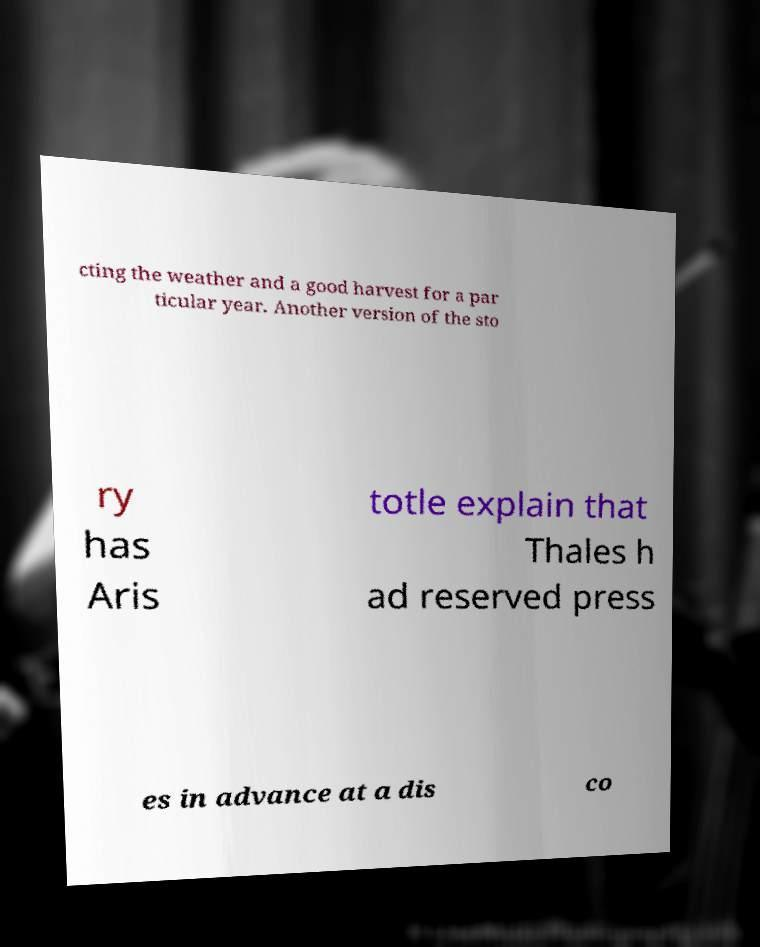Please read and relay the text visible in this image. What does it say? cting the weather and a good harvest for a par ticular year. Another version of the sto ry has Aris totle explain that Thales h ad reserved press es in advance at a dis co 